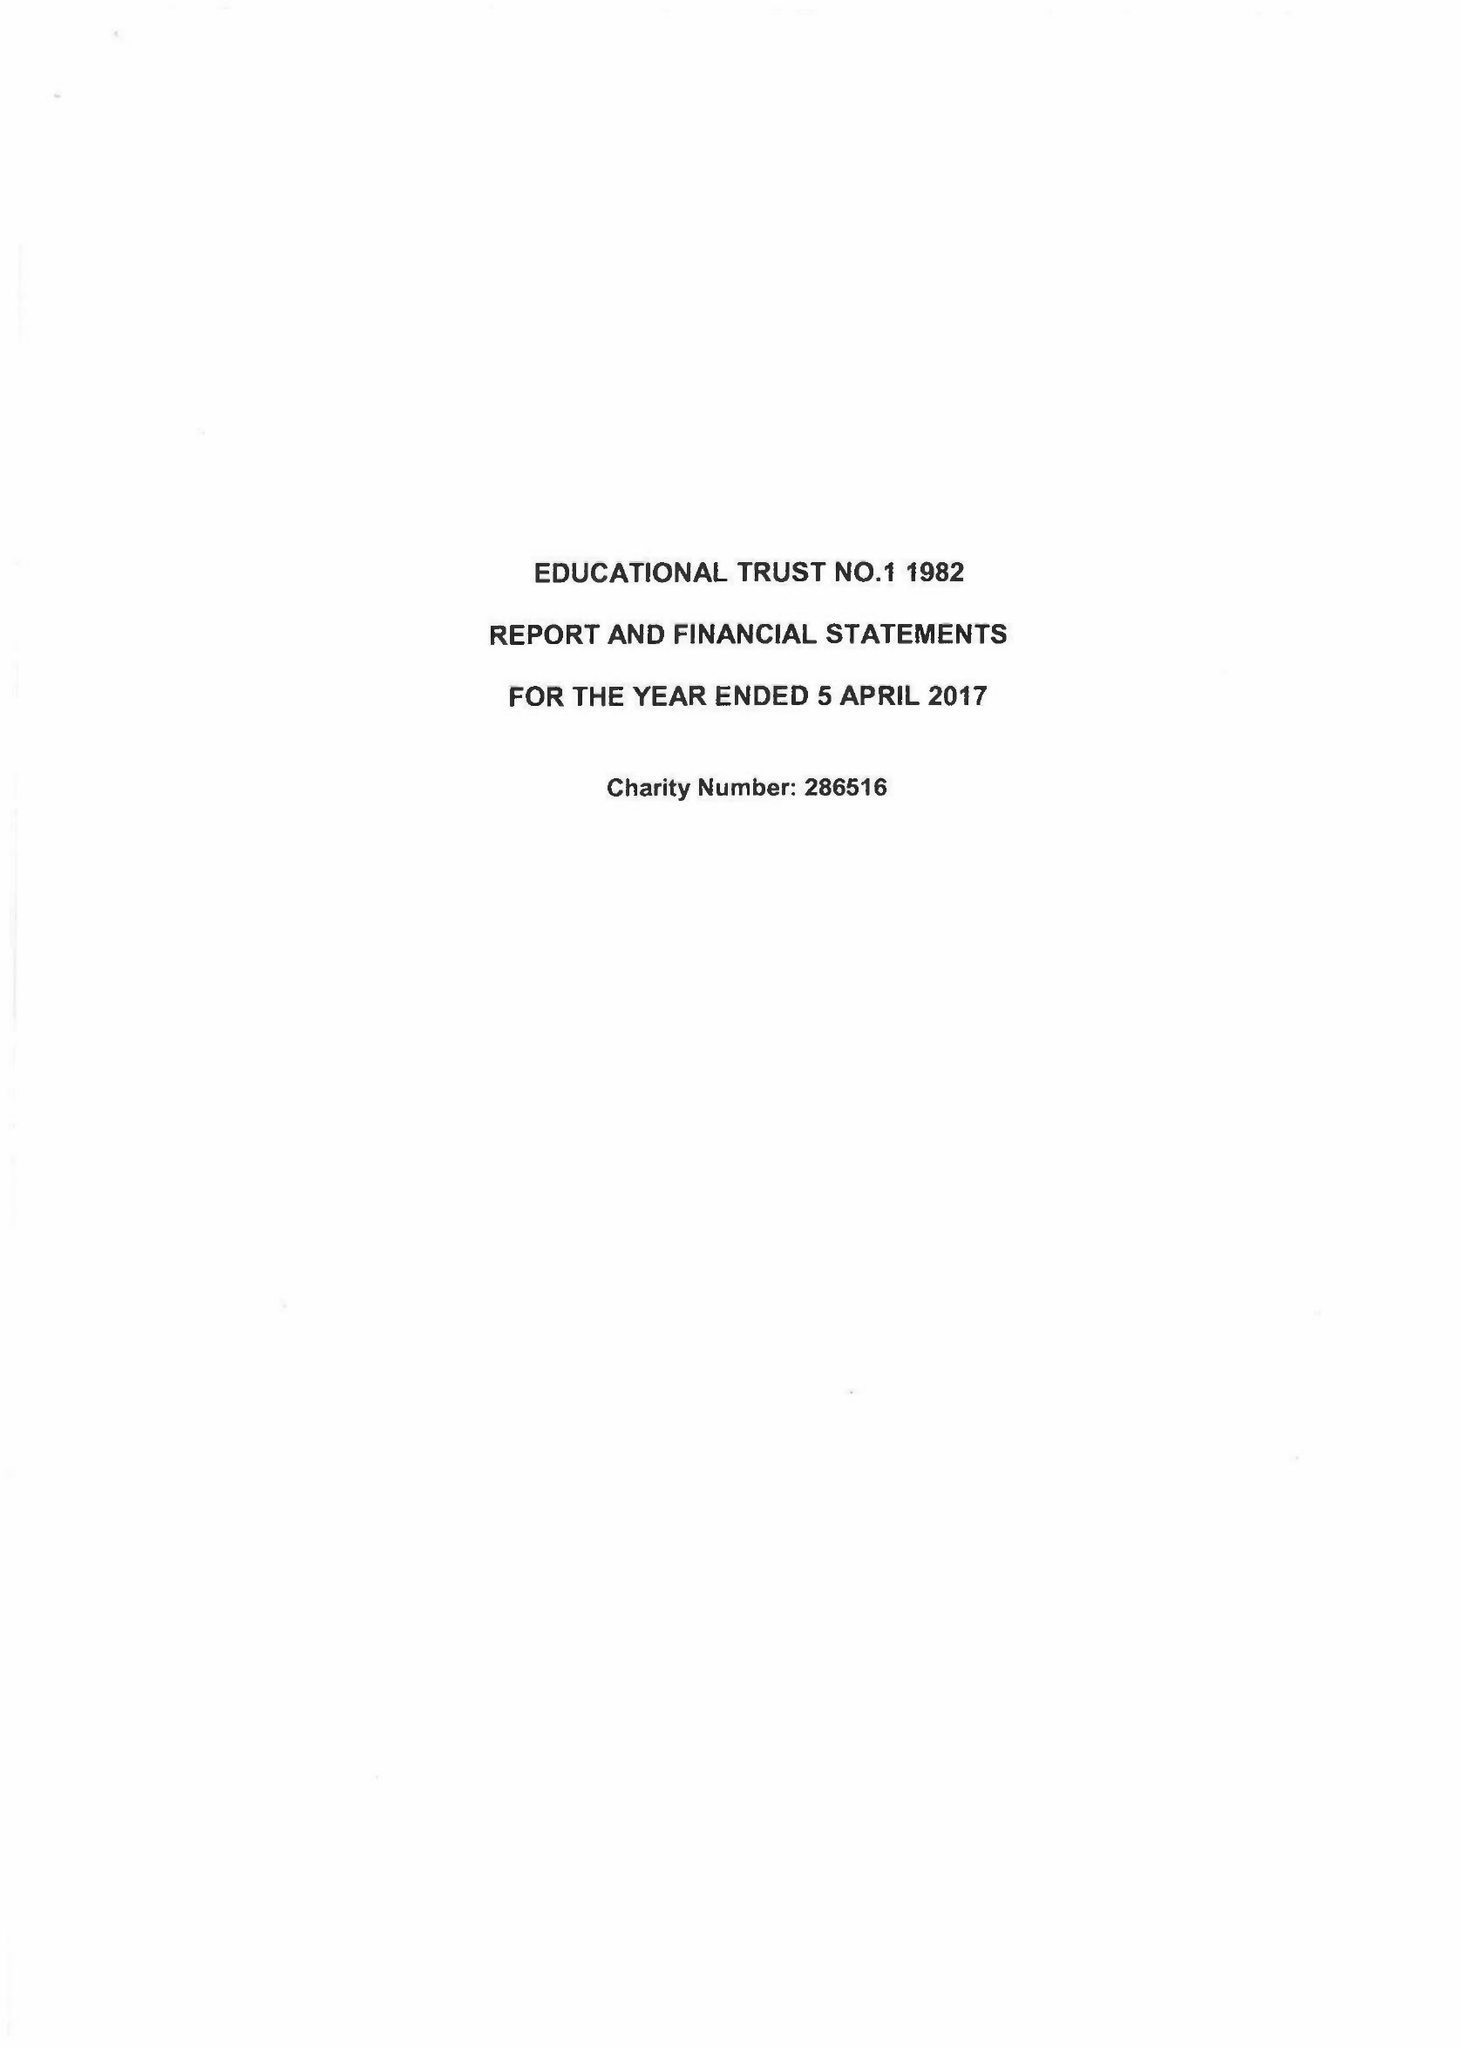What is the value for the income_annually_in_british_pounds?
Answer the question using a single word or phrase. 83862.00 